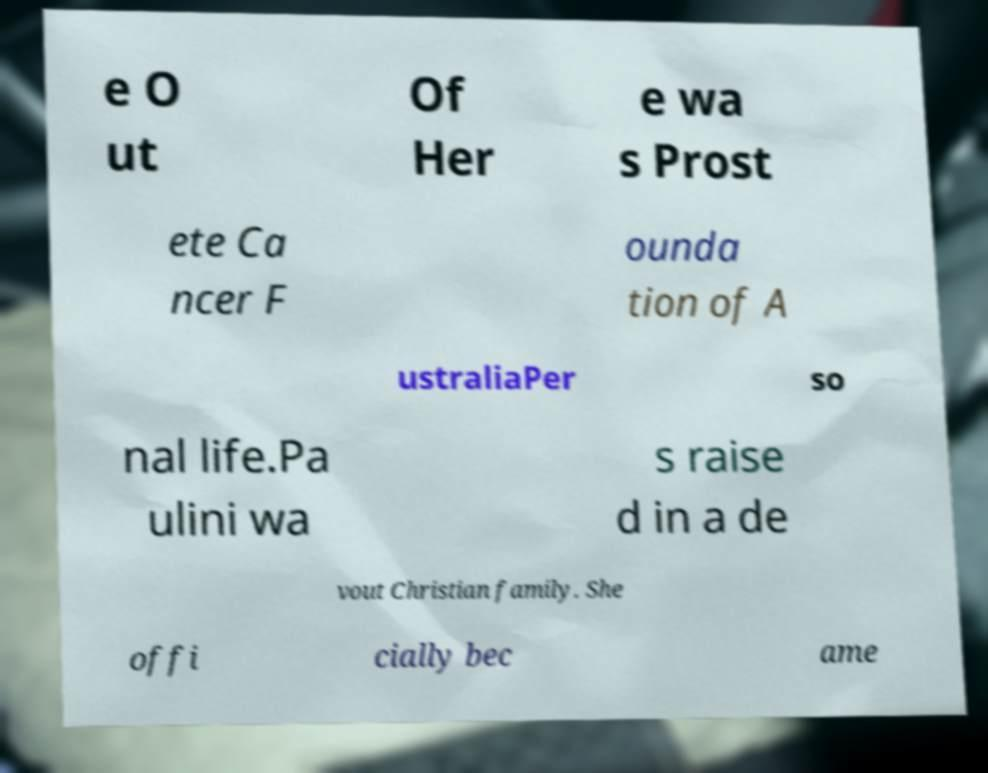Can you accurately transcribe the text from the provided image for me? e O ut Of Her e wa s Prost ete Ca ncer F ounda tion of A ustraliaPer so nal life.Pa ulini wa s raise d in a de vout Christian family. She offi cially bec ame 